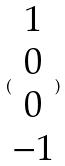Convert formula to latex. <formula><loc_0><loc_0><loc_500><loc_500>( \begin{matrix} 1 \\ 0 \\ 0 \\ - 1 \end{matrix} )</formula> 